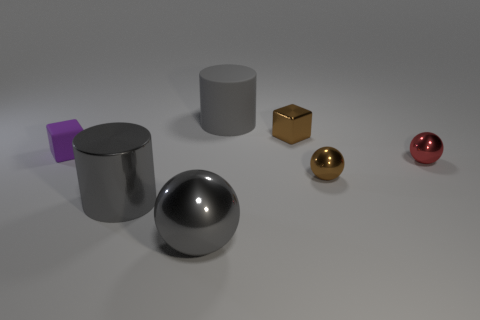Add 3 big gray balls. How many objects exist? 10 Subtract all balls. How many objects are left? 4 Subtract all tiny red metallic balls. Subtract all gray objects. How many objects are left? 3 Add 4 brown metallic cubes. How many brown metallic cubes are left? 5 Add 2 small purple objects. How many small purple objects exist? 3 Subtract 2 gray cylinders. How many objects are left? 5 